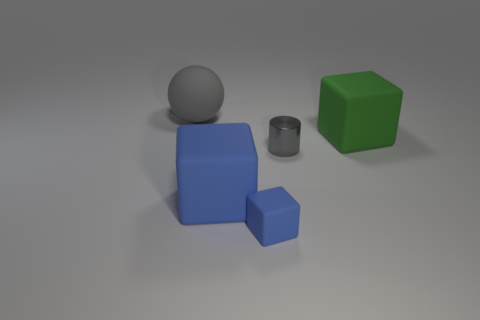There is a large cube on the left side of the rubber object right of the gray object right of the large ball; what is it made of?
Provide a short and direct response. Rubber. How many cylinders are either green objects or gray rubber things?
Provide a short and direct response. 0. There is a small block that is in front of the big rubber cube that is in front of the large green block; how many blocks are to the left of it?
Provide a short and direct response. 1. Do the large green thing and the big blue rubber thing have the same shape?
Your answer should be very brief. Yes. Is the blue object that is behind the tiny matte cube made of the same material as the gray object behind the gray cylinder?
Your answer should be compact. Yes. What number of things are either cubes that are in front of the big green thing or rubber objects behind the tiny shiny cylinder?
Your answer should be compact. 4. Is there any other thing that has the same shape as the small rubber thing?
Provide a short and direct response. Yes. What number of big gray matte cylinders are there?
Provide a succinct answer. 0. Is there a blue rubber cube of the same size as the metal cylinder?
Provide a succinct answer. Yes. Is the material of the green block the same as the gray thing that is in front of the large gray matte ball?
Ensure brevity in your answer.  No. 